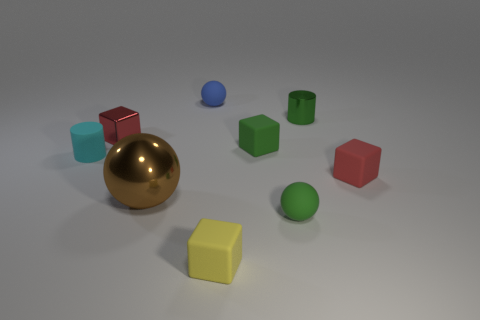What number of small red metallic cubes are behind the tiny cyan cylinder?
Make the answer very short. 1. What is the size of the brown shiny sphere on the right side of the cube that is to the left of the matte sphere that is behind the small green cube?
Give a very brief answer. Large. There is a cyan rubber thing; does it have the same shape as the tiny object in front of the green matte sphere?
Give a very brief answer. No. The brown thing that is the same material as the green cylinder is what size?
Provide a short and direct response. Large. Is there any other thing that has the same color as the tiny matte cylinder?
Make the answer very short. No. There is a tiny green thing that is in front of the rubber object on the left side of the small red object to the left of the small yellow block; what is it made of?
Ensure brevity in your answer.  Rubber. What number of matte objects are either tiny red cylinders or tiny things?
Your answer should be compact. 6. What number of objects are yellow cubes or red things right of the blue ball?
Your answer should be very brief. 2. There is a cylinder that is in front of the metal cylinder; is its size the same as the brown metallic sphere?
Keep it short and to the point. No. How many other things are there of the same shape as the green shiny object?
Give a very brief answer. 1. 